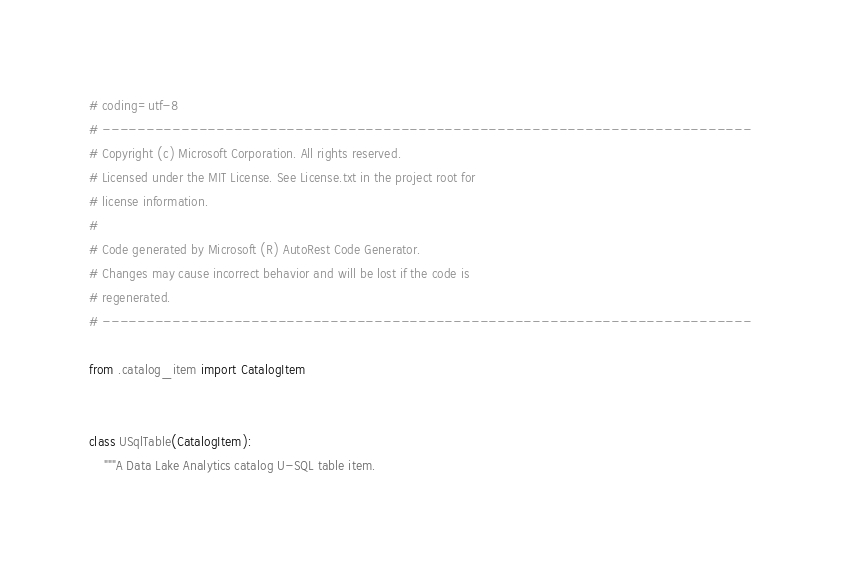<code> <loc_0><loc_0><loc_500><loc_500><_Python_># coding=utf-8
# --------------------------------------------------------------------------
# Copyright (c) Microsoft Corporation. All rights reserved.
# Licensed under the MIT License. See License.txt in the project root for
# license information.
#
# Code generated by Microsoft (R) AutoRest Code Generator.
# Changes may cause incorrect behavior and will be lost if the code is
# regenerated.
# --------------------------------------------------------------------------

from .catalog_item import CatalogItem


class USqlTable(CatalogItem):
    """A Data Lake Analytics catalog U-SQL table item.
</code> 